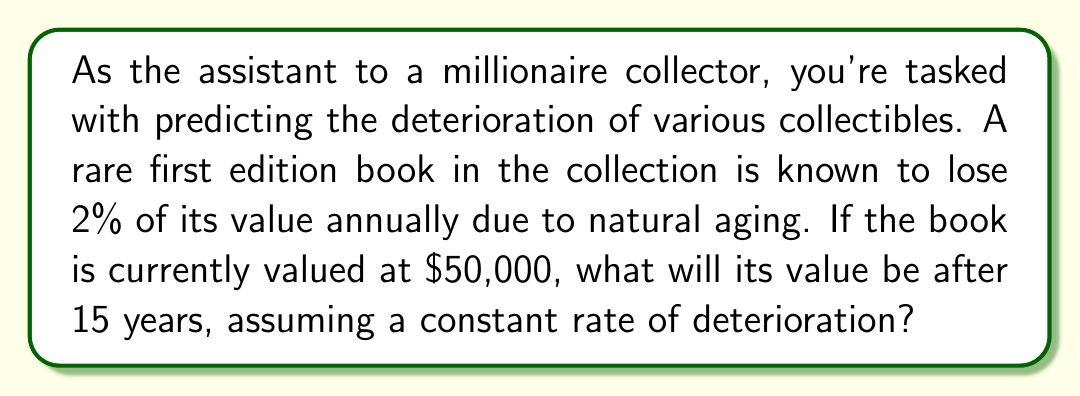Help me with this question. To solve this problem, we need to use the concept of exponential decay, as the book's value is decreasing by a fixed percentage each year.

Let's define our variables:
$P_0$ = Initial value = $50,000
$r$ = Annual rate of deterioration = 2% = 0.02
$t$ = Time in years = 15
$P$ = Final value after 15 years

The formula for exponential decay is:

$$ P = P_0 \cdot (1-r)^t $$

Substituting our values:

$$ P = 50000 \cdot (1-0.02)^{15} $$

Now, let's calculate step-by-step:

1) First, calculate $(1-0.02)^{15}$:
   $$(1-0.02)^{15} = 0.98^{15} \approx 0.7397$$

2) Multiply this by the initial value:
   $$50000 \cdot 0.7397 \approx 36,985$$

Therefore, after 15 years, the book's value will be approximately $36,985.
Answer: $36,985 